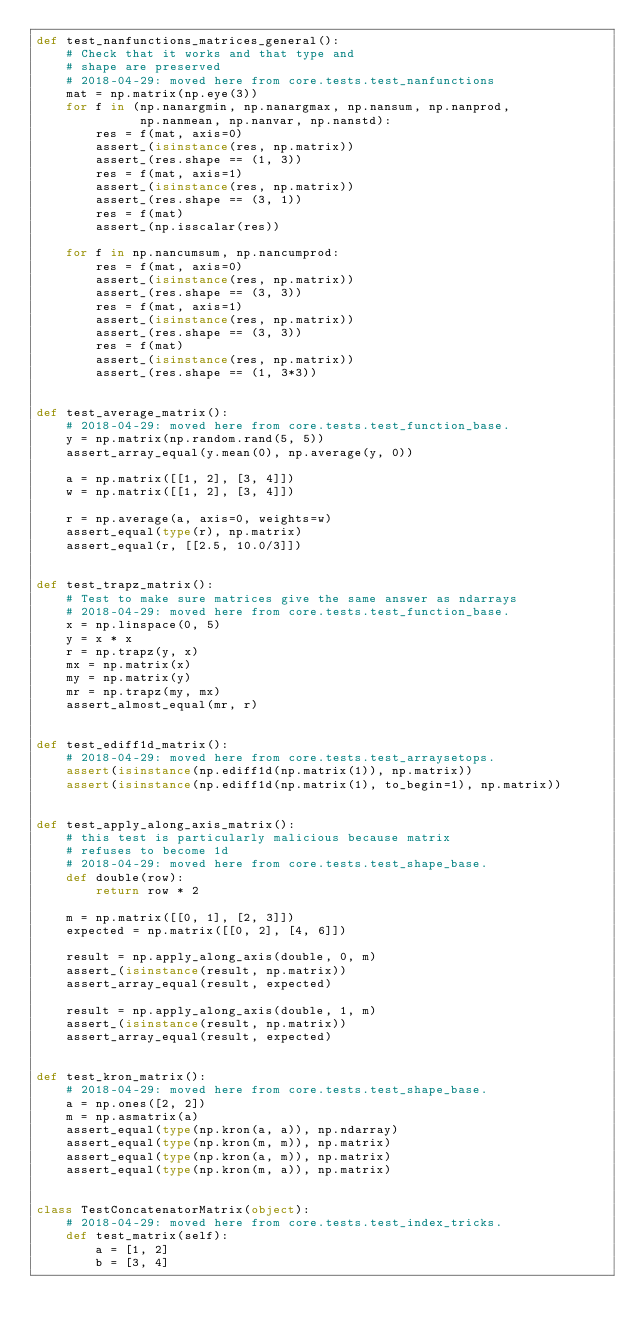<code> <loc_0><loc_0><loc_500><loc_500><_Python_>def test_nanfunctions_matrices_general():
    # Check that it works and that type and
    # shape are preserved
    # 2018-04-29: moved here from core.tests.test_nanfunctions
    mat = np.matrix(np.eye(3))
    for f in (np.nanargmin, np.nanargmax, np.nansum, np.nanprod,
              np.nanmean, np.nanvar, np.nanstd):
        res = f(mat, axis=0)
        assert_(isinstance(res, np.matrix))
        assert_(res.shape == (1, 3))
        res = f(mat, axis=1)
        assert_(isinstance(res, np.matrix))
        assert_(res.shape == (3, 1))
        res = f(mat)
        assert_(np.isscalar(res))

    for f in np.nancumsum, np.nancumprod:
        res = f(mat, axis=0)
        assert_(isinstance(res, np.matrix))
        assert_(res.shape == (3, 3))
        res = f(mat, axis=1)
        assert_(isinstance(res, np.matrix))
        assert_(res.shape == (3, 3))
        res = f(mat)
        assert_(isinstance(res, np.matrix))
        assert_(res.shape == (1, 3*3))


def test_average_matrix():
    # 2018-04-29: moved here from core.tests.test_function_base.
    y = np.matrix(np.random.rand(5, 5))
    assert_array_equal(y.mean(0), np.average(y, 0))

    a = np.matrix([[1, 2], [3, 4]])
    w = np.matrix([[1, 2], [3, 4]])

    r = np.average(a, axis=0, weights=w)
    assert_equal(type(r), np.matrix)
    assert_equal(r, [[2.5, 10.0/3]])


def test_trapz_matrix():
    # Test to make sure matrices give the same answer as ndarrays
    # 2018-04-29: moved here from core.tests.test_function_base.
    x = np.linspace(0, 5)
    y = x * x
    r = np.trapz(y, x)
    mx = np.matrix(x)
    my = np.matrix(y)
    mr = np.trapz(my, mx)
    assert_almost_equal(mr, r)


def test_ediff1d_matrix():
    # 2018-04-29: moved here from core.tests.test_arraysetops.
    assert(isinstance(np.ediff1d(np.matrix(1)), np.matrix))
    assert(isinstance(np.ediff1d(np.matrix(1), to_begin=1), np.matrix))


def test_apply_along_axis_matrix():
    # this test is particularly malicious because matrix
    # refuses to become 1d
    # 2018-04-29: moved here from core.tests.test_shape_base.
    def double(row):
        return row * 2

    m = np.matrix([[0, 1], [2, 3]])
    expected = np.matrix([[0, 2], [4, 6]])

    result = np.apply_along_axis(double, 0, m)
    assert_(isinstance(result, np.matrix))
    assert_array_equal(result, expected)

    result = np.apply_along_axis(double, 1, m)
    assert_(isinstance(result, np.matrix))
    assert_array_equal(result, expected)


def test_kron_matrix():
    # 2018-04-29: moved here from core.tests.test_shape_base.
    a = np.ones([2, 2])
    m = np.asmatrix(a)
    assert_equal(type(np.kron(a, a)), np.ndarray)
    assert_equal(type(np.kron(m, m)), np.matrix)
    assert_equal(type(np.kron(a, m)), np.matrix)
    assert_equal(type(np.kron(m, a)), np.matrix)


class TestConcatenatorMatrix(object):
    # 2018-04-29: moved here from core.tests.test_index_tricks.
    def test_matrix(self):
        a = [1, 2]
        b = [3, 4]
</code> 